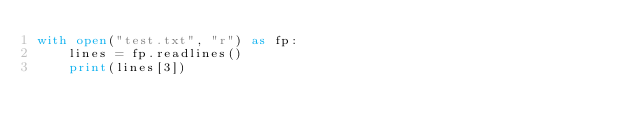<code> <loc_0><loc_0><loc_500><loc_500><_Python_>with open("test.txt", "r") as fp:
    lines = fp.readlines()
    print(lines[3])</code> 